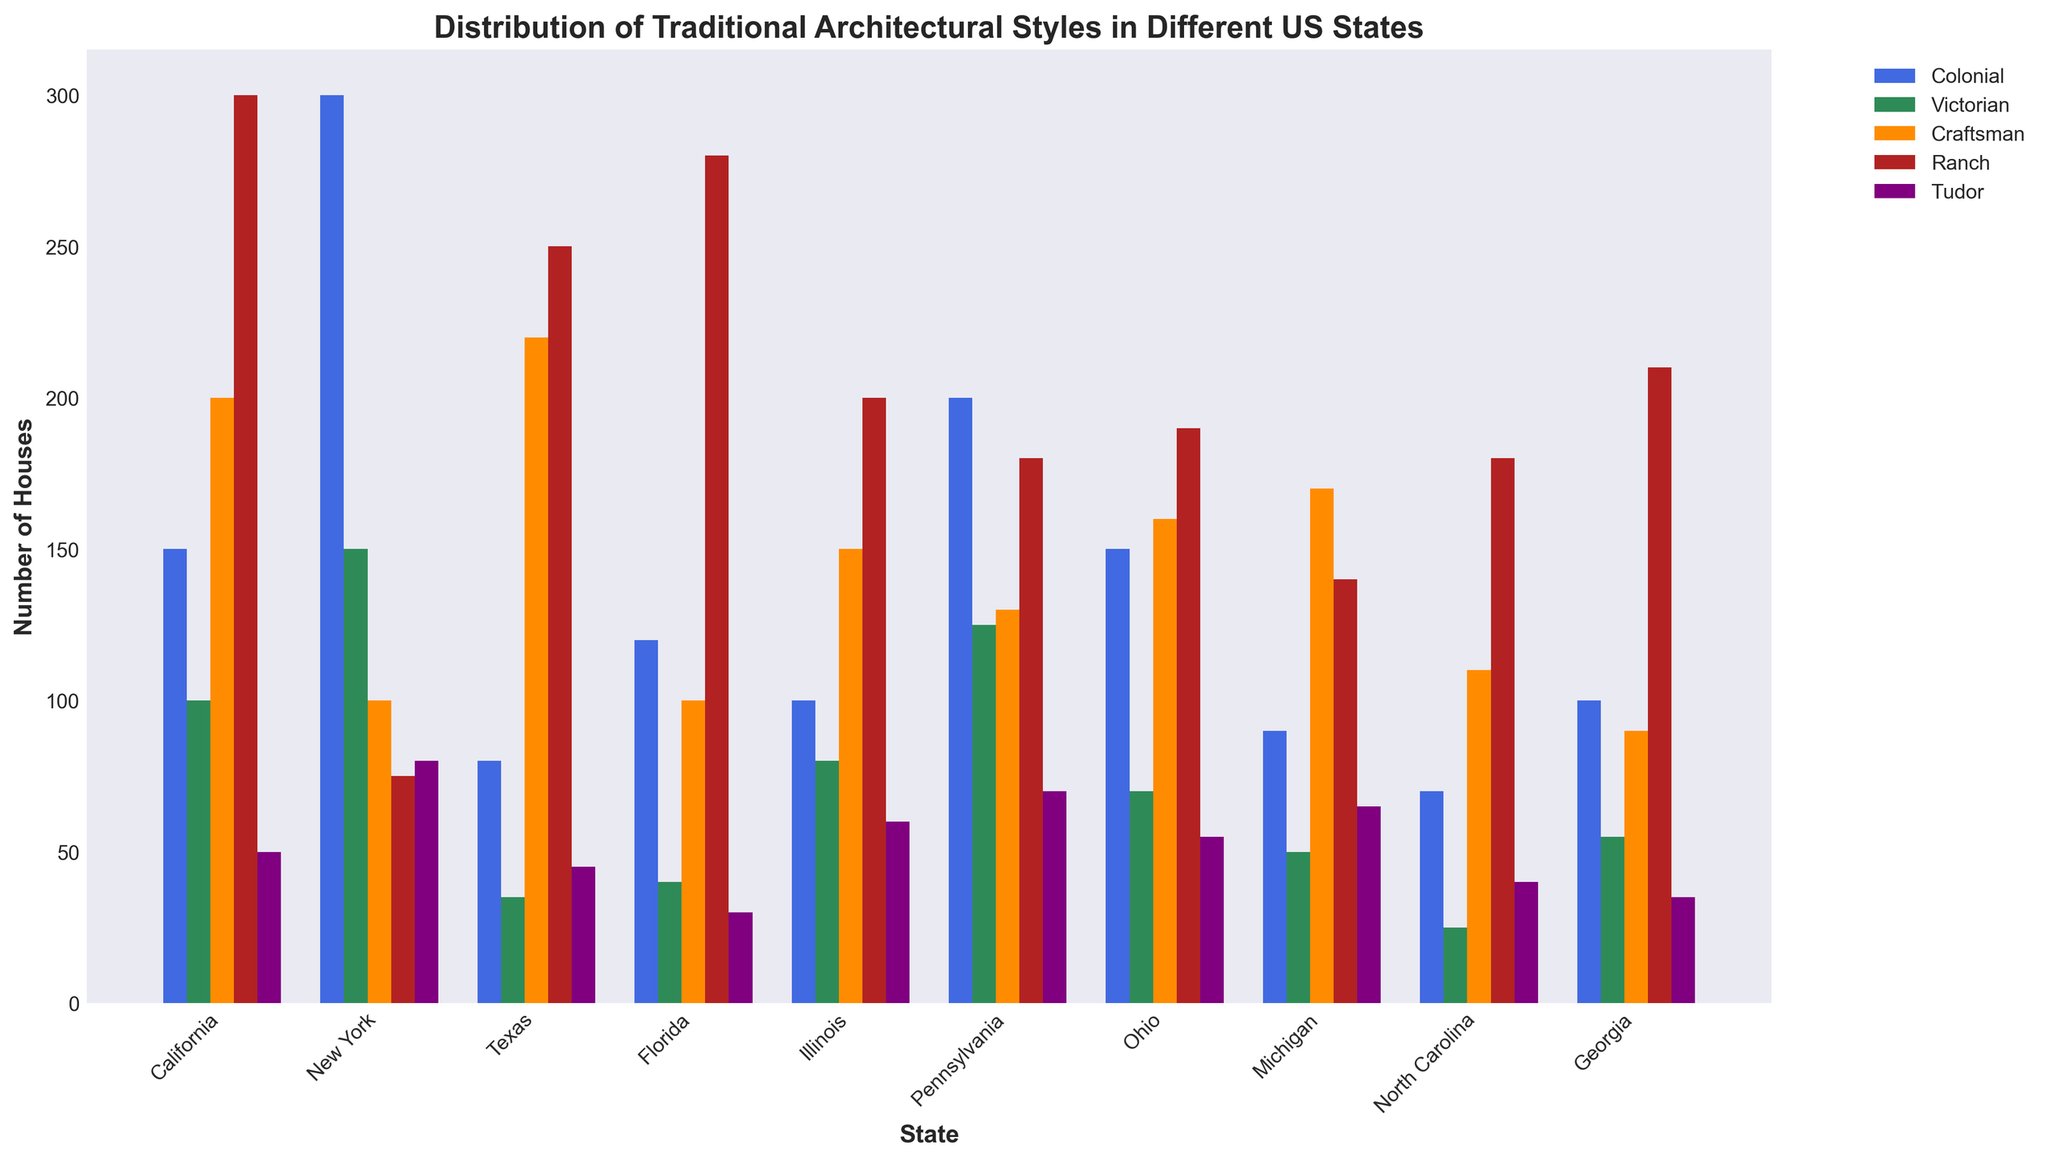What is the total number of houses with Traditional Colonial style in New York and Pennsylvania combined? To find the total number of houses with Traditional Colonial style in New York and Pennsylvania combined, add the values: 300 (New York) + 200 (Pennsylvania) = 500
Answer: 500 Which state has the highest number of Traditional Craftsman houses, and what is that number? By comparing the Traditional Craftsman values for each state, California has the highest number with 200 houses.
Answer: California, 200 How many more Traditional Ranch style houses are there in Texas than in Michigan? To find out how many more Traditional Ranch style houses there are in Texas compared to Michigan, subtract the values: 250 (Texas) - 140 (Michigan) = 110
Answer: 110 Which architectural style has the most houses in Florida? By comparing the height of the bars for each architectural style in Florida, the Traditional Ranch style (red bar) is the highest.
Answer: Traditional Ranch What is the combined number of Traditional Tudor houses in Ohio, Georgia, and North Carolina? To find the combined number of Traditional Tudor houses in Ohio, Georgia, and North Carolina, add the values: 55 (Ohio) + 35 (Georgia) + 40 (North Carolina) = 130
Answer: 130 What is the average number of Traditional Colonial houses across all listed states? To find the average, add all the Traditional Colonial houses values and then divide by the number of states: (150+300+80+120+100+200+150+90+70+100)/10 = 136
Answer: 136 Does Illinois have more Traditional Victorian or Traditional Tudor houses, and by how much? Compare the number of Traditional Victorian (80) and Traditional Tudor (60) houses in Illinois. There are 20 more Traditional Victorian houses: 80 - 60 = 20
Answer: Traditional Victorian, 20 Which state has the least amount of Traditional Victorian houses, and what number is it? By comparing the Traditional Victorian values for each state, North Carolina has the least with 25 houses.
Answer: North Carolina, 25 How does the number of Traditional Craftsman houses in Texas compare to those in California? Compare the number of Traditional Craftsman houses: Texas has 220, and California has 200. Texas has more Traditional Craftsman houses.
Answer: Texas, more What is the total number of Traditional Ranch houses in the top three states with the highest counts for this style? Identify the top three states with the highest Traditional Ranch houses: California (300), Florida (280), and Texas (250). Add their values: 300 + 280 + 250 = 830
Answer: 830 